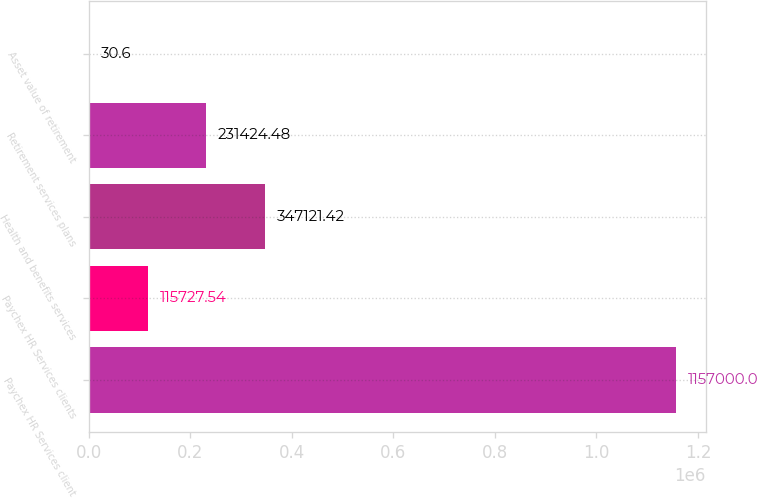Convert chart. <chart><loc_0><loc_0><loc_500><loc_500><bar_chart><fcel>Paychex HR Services client<fcel>Paychex HR Services clients<fcel>Health and benefits services<fcel>Retirement services plans<fcel>Asset value of retirement<nl><fcel>1.157e+06<fcel>115728<fcel>347121<fcel>231424<fcel>30.6<nl></chart> 